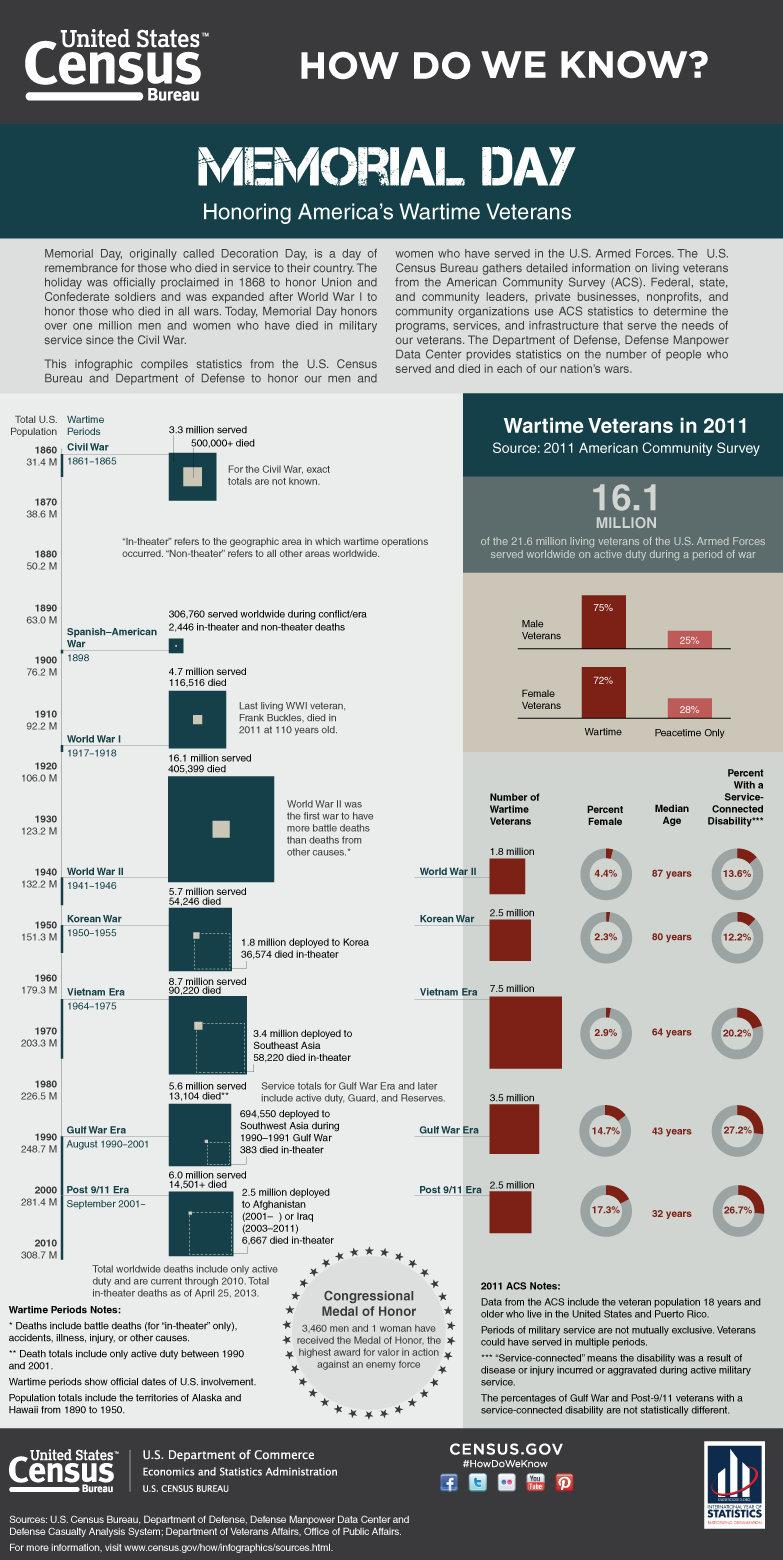Draw attention to some important aspects in this diagram. During World War II, approximately 4.4% of veterans were female. It is estimated that 3,460 men have been awarded the Medal of Honor. Memorial Day is the day of remembrance for those who died in service to their country. 